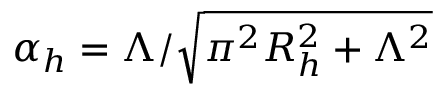<formula> <loc_0><loc_0><loc_500><loc_500>\alpha _ { h } = \Lambda / \sqrt { \pi ^ { 2 } R _ { h } ^ { 2 } + \Lambda ^ { 2 } }</formula> 